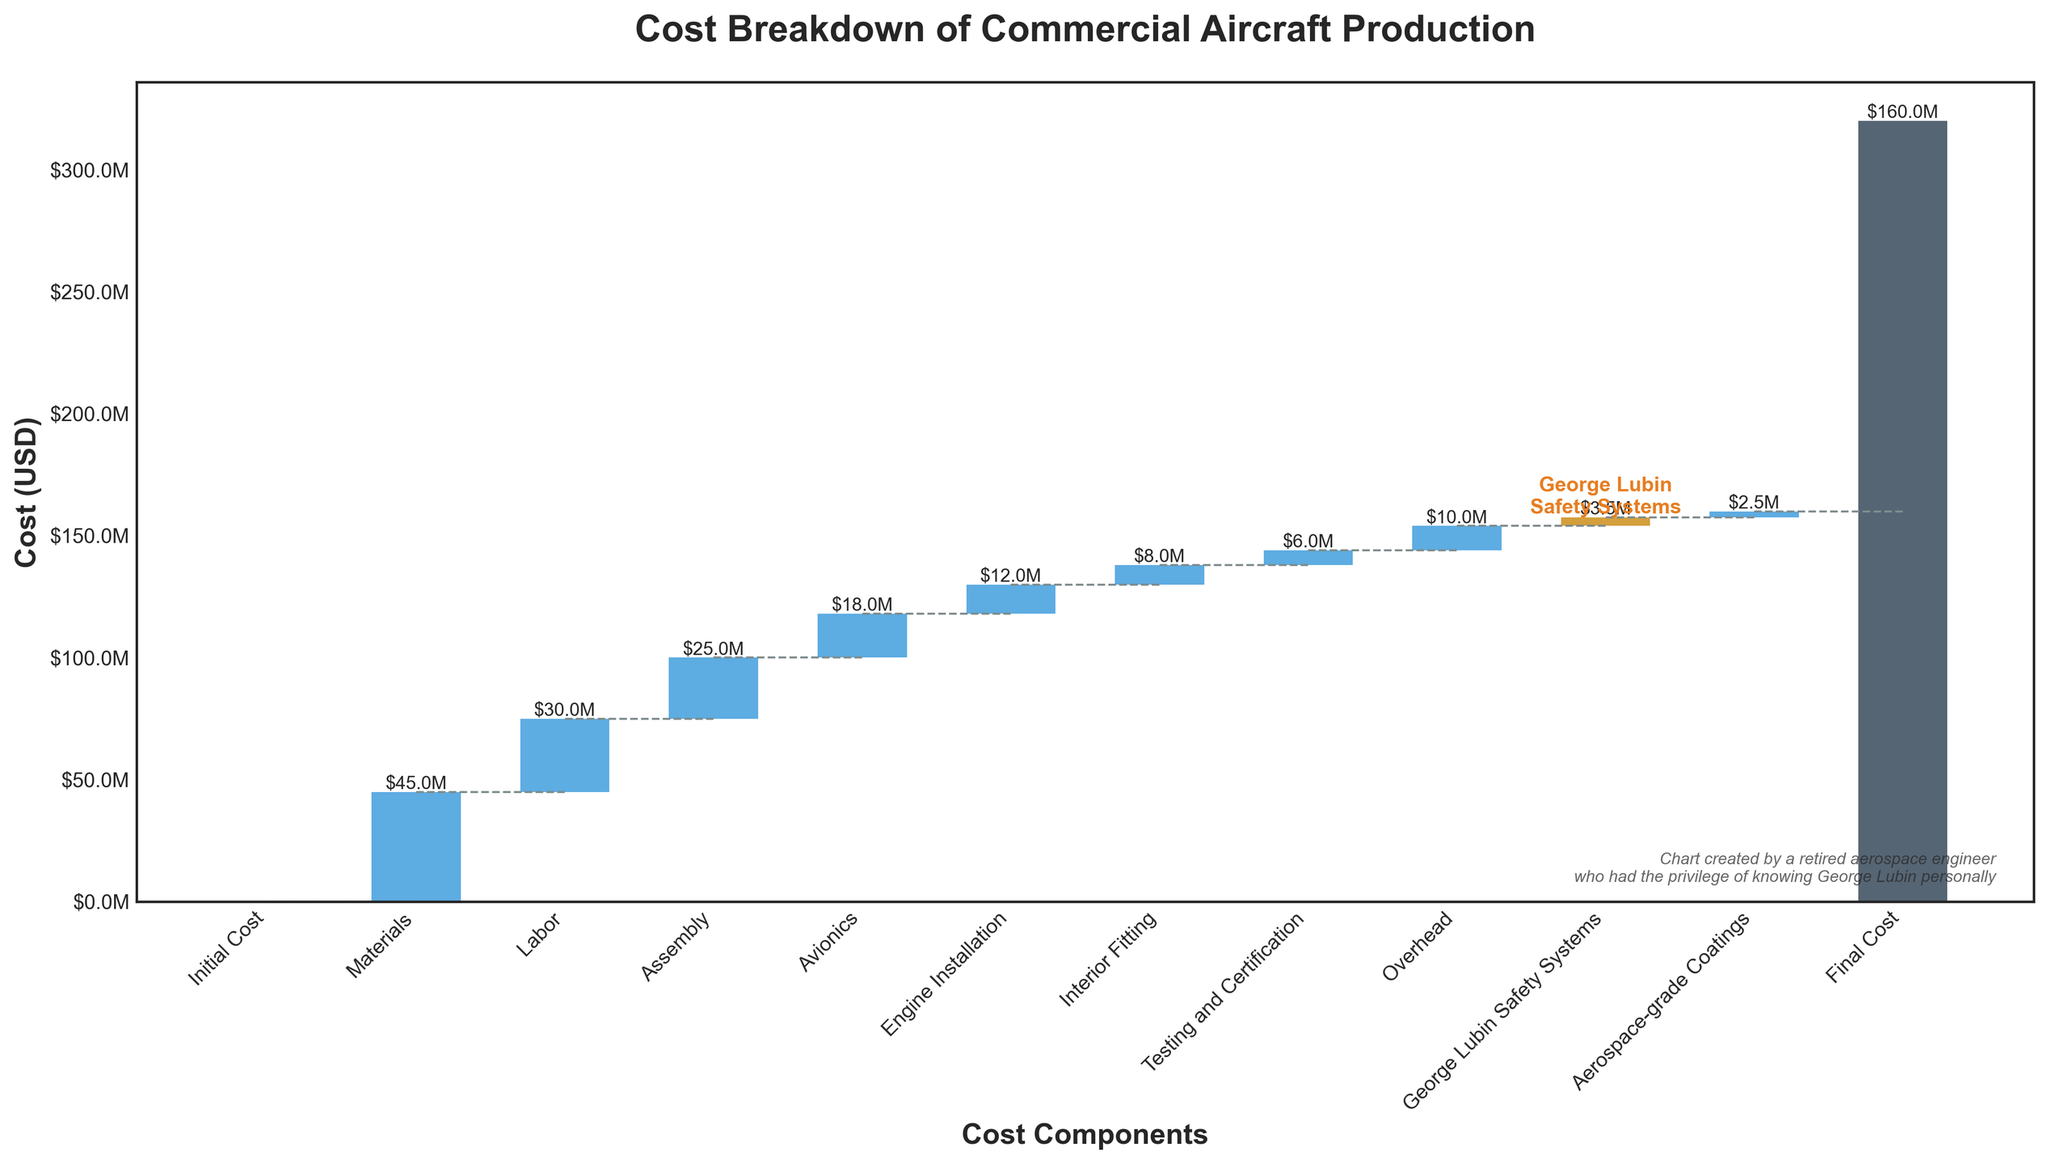What is the title of the chart? The title of the chart is typically displayed at the top of the figure. In this case, we can see from the provided code the title is defined as 'Cost Breakdown of Commercial Aircraft Production.'
Answer: Cost Breakdown of Commercial Aircraft Production Which cost component has the highest value? The values of each cost component are shown on the bars. The largest bar corresponds to 'Materials,' which is $45 million.
Answer: Materials How much does the 'George Lubin Safety Systems' contribute to the final cost? The 'George Lubin Safety Systems' component is specifically highlighted in the chart, with a value of $3.5 million labeled on the bar.
Answer: $3.5 million What is the sum of 'Avionics' and 'Engine Installation' costs? The values for 'Avionics' and 'Engine Installation' are provided as $18 million and $12 million respectively. Summing these values gives $30 million.
Answer: $30 million Which costs are lower than $10 million? The bars with values representing components lower than $10 million are 'Interior Fitting' ($8 million), 'Testing and Certification' ($6 million), 'George Lubin Safety Systems' ($3.5 million), and 'Aerospace-grade Coatings' ($2.5 million).
Answer: Interior Fitting, Testing and Certification, George Lubin Safety Systems, Aerospace-grade Coatings What are the beginning and final costs represented in the chart? The beginning cost is represented by 'Initial Cost' at the start and the final cost is represented by 'Final Cost' at the end of the waterfall. 'Initial Cost' is $0, and 'Final Cost' is $160 million.
Answer: $0 and $160 million How much more is spent on 'Materials' compared to 'Avionics'? The cost for 'Materials' is $45 million, and for 'Avionics' is $18 million. The difference is $45 million - $18 million = $27 million.
Answer: $27 million What is the total cost associated with 'Labor,' 'Assembly,' and 'Overhead'? Summing the values for 'Labor' ($30 million), 'Assembly' ($25 million), and 'Overhead' ($10 million) gives $65 million.
Answer: $65 million In the chart, which color is used to highlight the 'George Lubin Safety Systems'? The code indicates that 'George Lubin Safety Systems' is highlighted in a unique gold/orange color for emphasis. This bar stands out from the other bars.
Answer: Gold/Orange 